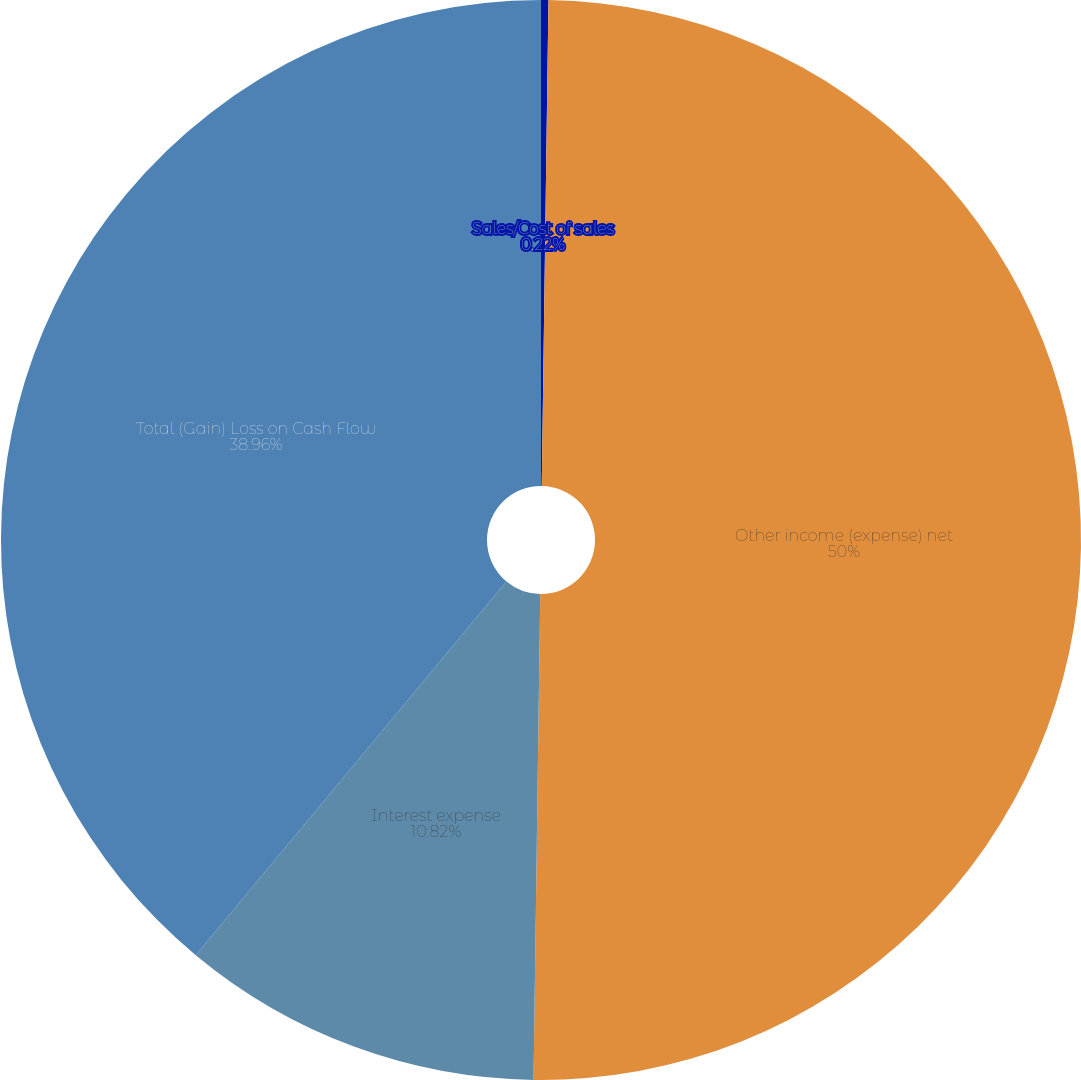Convert chart. <chart><loc_0><loc_0><loc_500><loc_500><pie_chart><fcel>Sales/Cost of sales<fcel>Other income (expense) net<fcel>Interest expense<fcel>Total (Gain) Loss on Cash Flow<nl><fcel>0.22%<fcel>50.0%<fcel>10.82%<fcel>38.96%<nl></chart> 